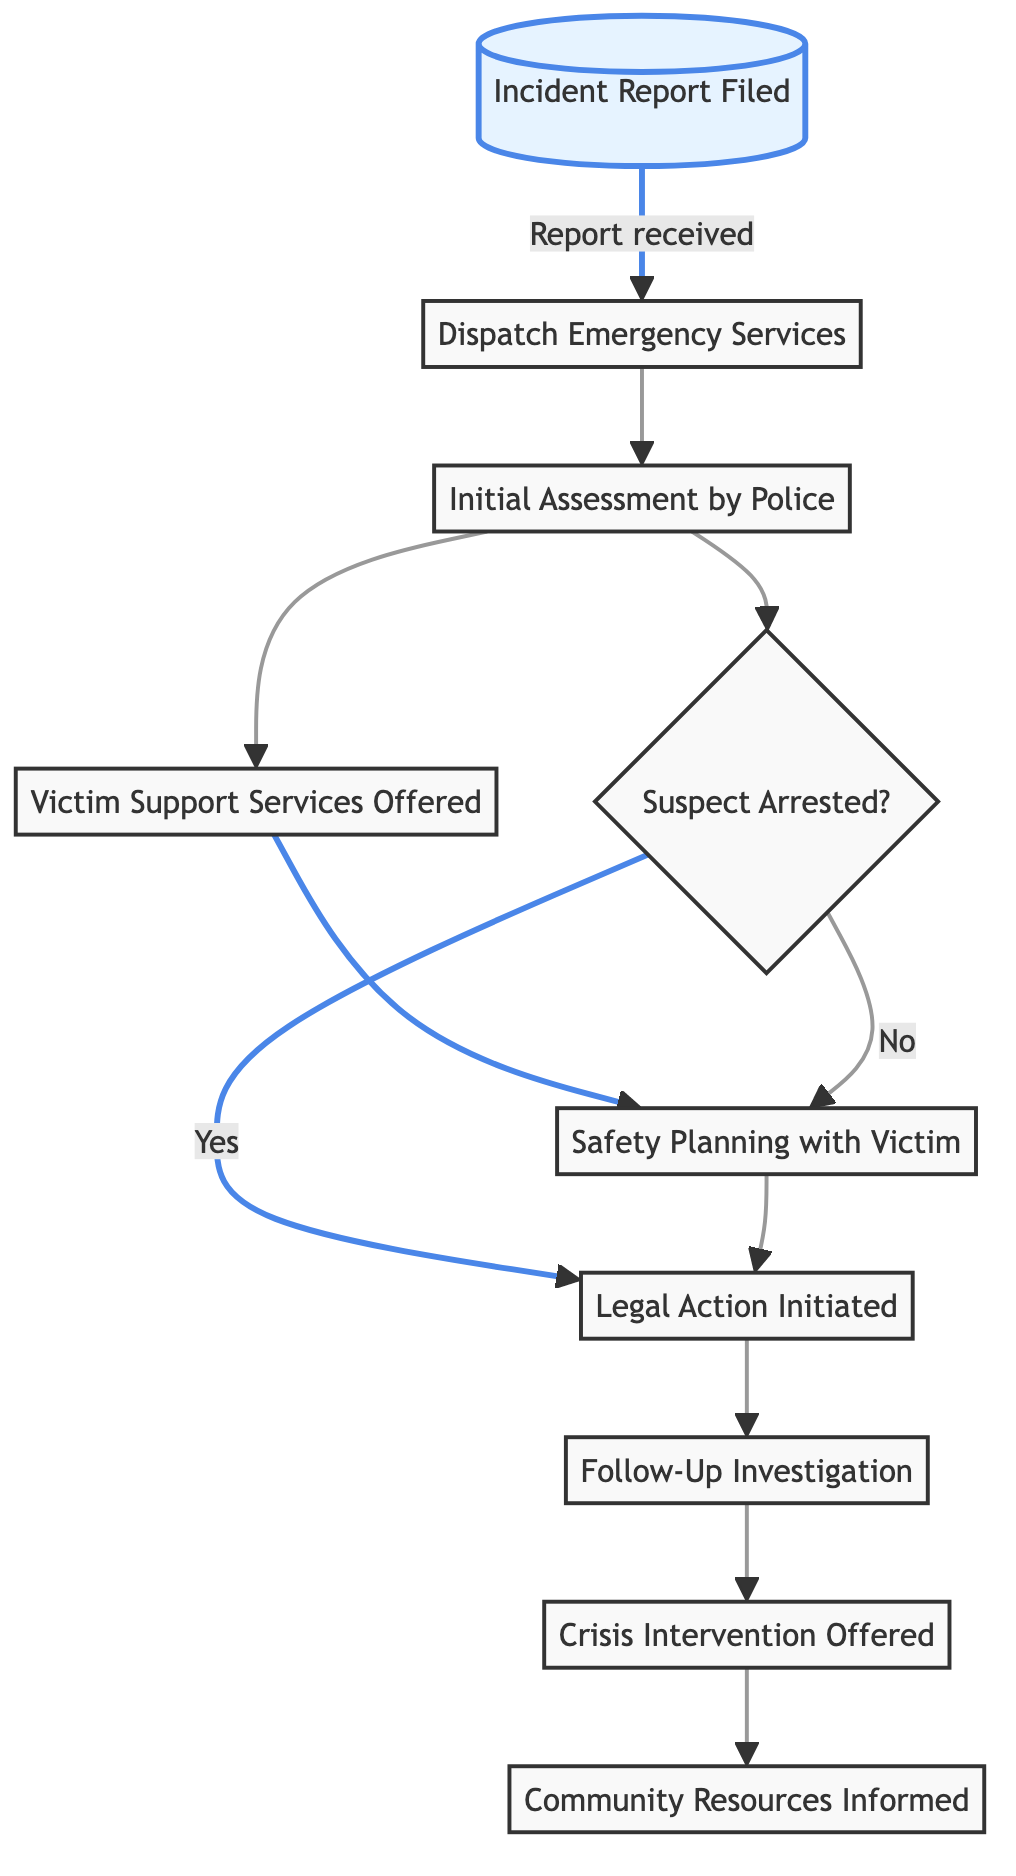What is the first step in the process? The diagram begins with the "Incident Report Filed" step, which indicates that the process starts when a report is made.
Answer: Incident Report Filed How many services offer Victim Support? After the "Initial Assessment by Police," there is a single step indicating "Victim Support Services Offered." Therefore, there is one direct service.
Answer: One What happens after the police assess the situation? Following the "Initial Assessment by Police," the next step is "Victim Support Services Offered," which demonstrates the support provided after the assessment.
Answer: Victim Support Services Offered What decision does the flow chart indicate? The diagram includes a decision node marked "Suspect Arrested?" which determines if the suspect will be arrested based on evidence of violence.
Answer: Suspect Arrested? How many nodes are there in total? By counting all the elements listed in the diagram, there are ten distinct nodes present within the flowchart.
Answer: Ten What step is taken if the suspect is not arrested? If the suspect is not arrested, the flowchart indicates that the process leads to "Safety Planning with Victim," suggesting an alternative support step for victims.
Answer: Safety Planning with Victim Which node comes after legal actions are initiated? The diagram indicates that after the "Legal Action Initiated," the next step is "Follow-Up Investigation," which continues the process.
Answer: Follow-Up Investigation What is the last step in the process? The final step listed in the flowchart is "Community Resources Informed," showing ongoing support provided at the conclusion of this response process.
Answer: Community Resources Informed What type of intervention is offered after the follow-up investigation? The flowchart shows that "Crisis Intervention Offered" is the next step after "Follow-Up Investigation," indicating further support provided to the victim.
Answer: Crisis Intervention Offered 